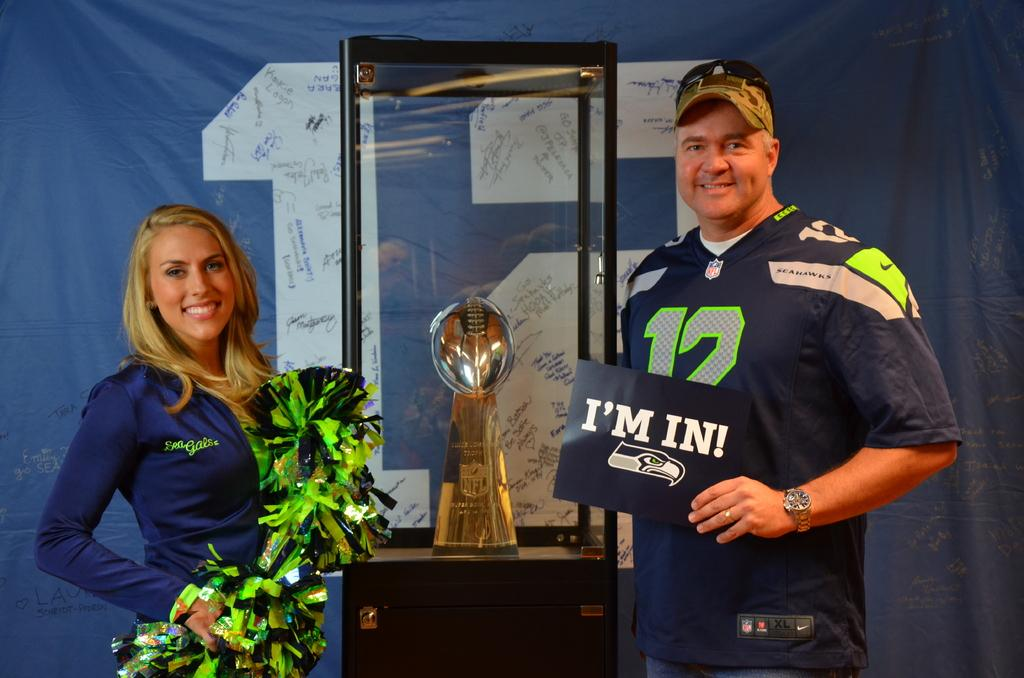<image>
Offer a succinct explanation of the picture presented. A SeaGals cheerleader poses on one side of a trophy case with a man wearing a #12 Seahawks jersey and holding a sign that says "I'm In" on the otherside. 